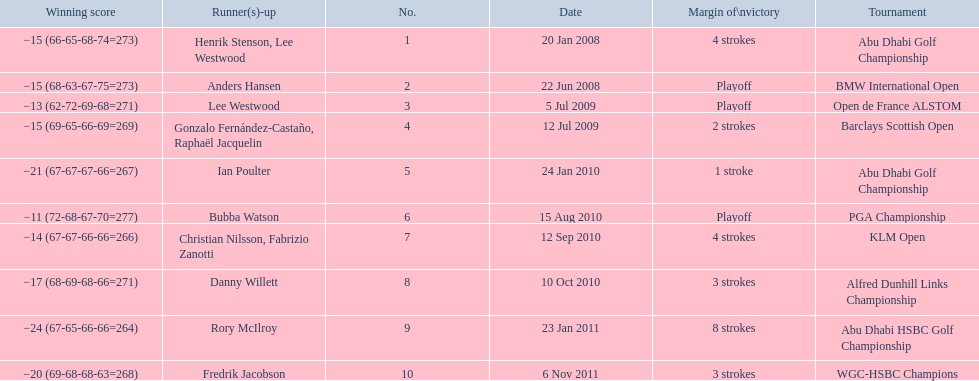How many strokes were in the klm open by martin kaymer? 4 strokes. How many strokes were in the abu dhabi golf championship? 4 strokes. How many more strokes were there in the klm than the barclays open? 2 strokes. Would you be able to parse every entry in this table? {'header': ['Winning score', 'Runner(s)-up', 'No.', 'Date', 'Margin of\\nvictory', 'Tournament'], 'rows': [['−15 (66-65-68-74=273)', 'Henrik Stenson, Lee Westwood', '1', '20 Jan 2008', '4 strokes', 'Abu Dhabi Golf Championship'], ['−15 (68-63-67-75=273)', 'Anders Hansen', '2', '22 Jun 2008', 'Playoff', 'BMW International Open'], ['−13 (62-72-69-68=271)', 'Lee Westwood', '3', '5 Jul 2009', 'Playoff', 'Open de France ALSTOM'], ['−15 (69-65-66-69=269)', 'Gonzalo Fernández-Castaño, Raphaël Jacquelin', '4', '12 Jul 2009', '2 strokes', 'Barclays Scottish Open'], ['−21 (67-67-67-66=267)', 'Ian Poulter', '5', '24 Jan 2010', '1 stroke', 'Abu Dhabi Golf Championship'], ['−11 (72-68-67-70=277)', 'Bubba Watson', '6', '15 Aug 2010', 'Playoff', 'PGA Championship'], ['−14 (67-67-66-66=266)', 'Christian Nilsson, Fabrizio Zanotti', '7', '12 Sep 2010', '4 strokes', 'KLM Open'], ['−17 (68-69-68-66=271)', 'Danny Willett', '8', '10 Oct 2010', '3 strokes', 'Alfred Dunhill Links Championship'], ['−24 (67-65-66-66=264)', 'Rory McIlroy', '9', '23 Jan 2011', '8 strokes', 'Abu Dhabi HSBC Golf Championship'], ['−20 (69-68-68-63=268)', 'Fredrik Jacobson', '10', '6 Nov 2011', '3 strokes', 'WGC-HSBC Champions']]} 